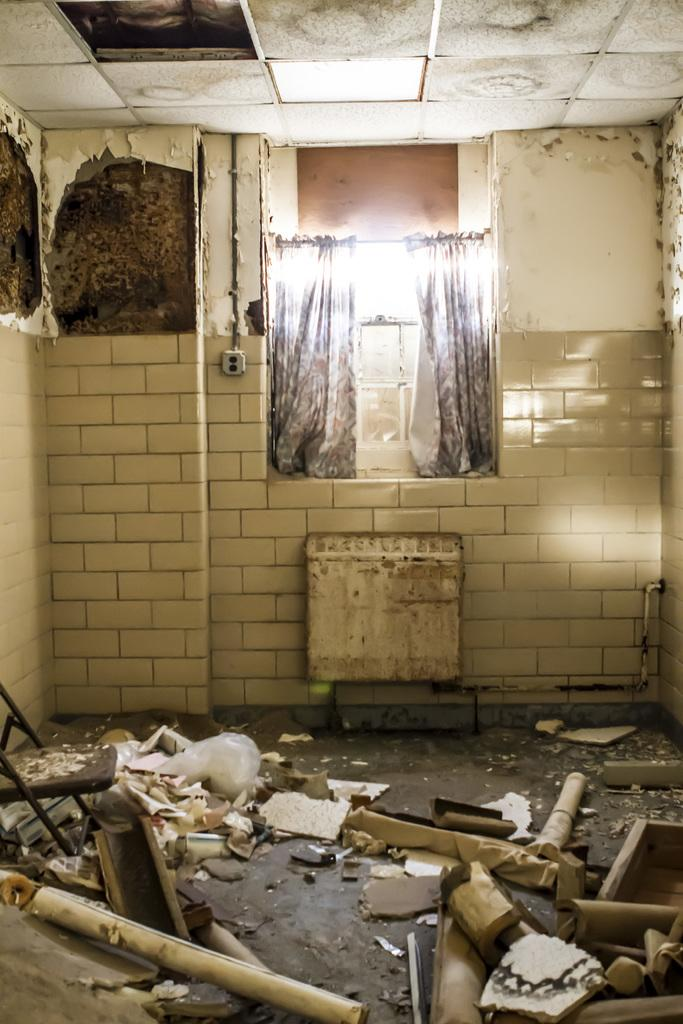What type of material is used for the objects in the image? The objects in the image are made of wood. Where is the chair located in the image? The chair is on a path in the image. What color is the white object in the image? The white object in the image is white. What type of wall is present in the image? There is a tile wall in the image. What is in the background of the image? There is a curtain and lights visible in the background of the image. What type of bomb is present in the image? There is no bomb present in the image. Who is the manager in the image? There is no manager present in the image. 